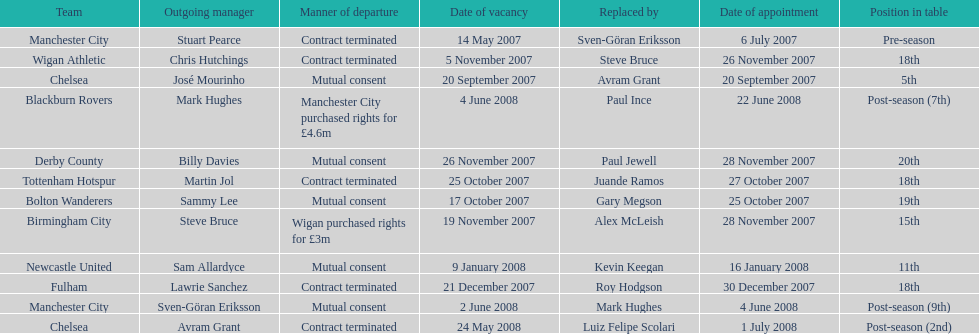How many years, at the very least, was avram grant with chelsea? 1. 